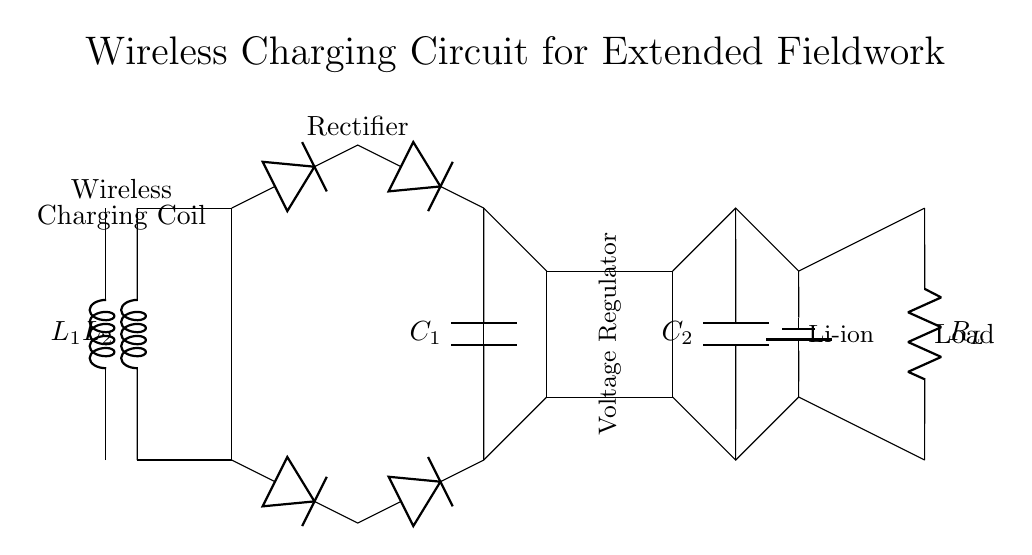What type of inductors are used in this circuit? The circuit shows two inductors labeled as L1 and L2, which are indicated in the diagram. These inductors are essential for creating the magnetic field required for wireless charging.
Answer: Inductors What component converts AC to DC in the circuit? The circuit diagram includes a rectifier bridge made of diodes, which is depicted connecting the inductors to the smoothing capacitor. This component is responsible for converting the alternating current (AC) generated by the inductors into direct current (DC).
Answer: Rectifier What is the purpose of the smoothing capacitor? The smoothing capacitor, labeled as C1 in the diagram, is placed after the rectifier. Its role is to filter the output from the rectifier to smooth the fluctuations in voltage, providing a more stable DC output for the voltage regulator.
Answer: Smoothing What does the voltage regulator do in this circuit? The voltage regulator, illustrated as a rectangular box in the circuit, maintains a constant output voltage despite changes in input voltage or load conditions. It ensures that the battery receives a stable input to charge effectively.
Answer: Stabilizes voltage How many batteries are depicted in this circuit? The circuit shows one battery labeled as a Li-ion battery, which provides the necessary energy storage for the circuit to function off-grid during fieldwork.
Answer: One Which component provides power to the load? The load is connected directly to the battery, which supplies power to it. Additionally, the voltage regulator prior to the load helps to ensure that the power delivered remains within operational limits for the connected load.
Answer: Battery 